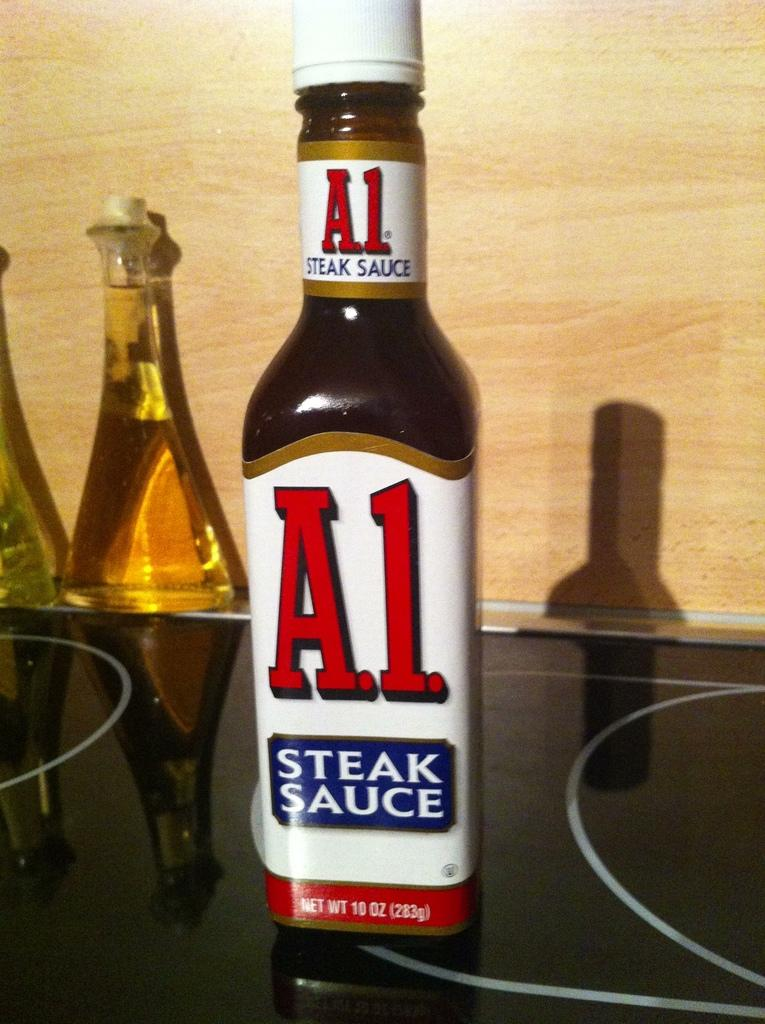<image>
Present a compact description of the photo's key features. A bottle of A.1. steak sauce contains 10 oz of sauce. 